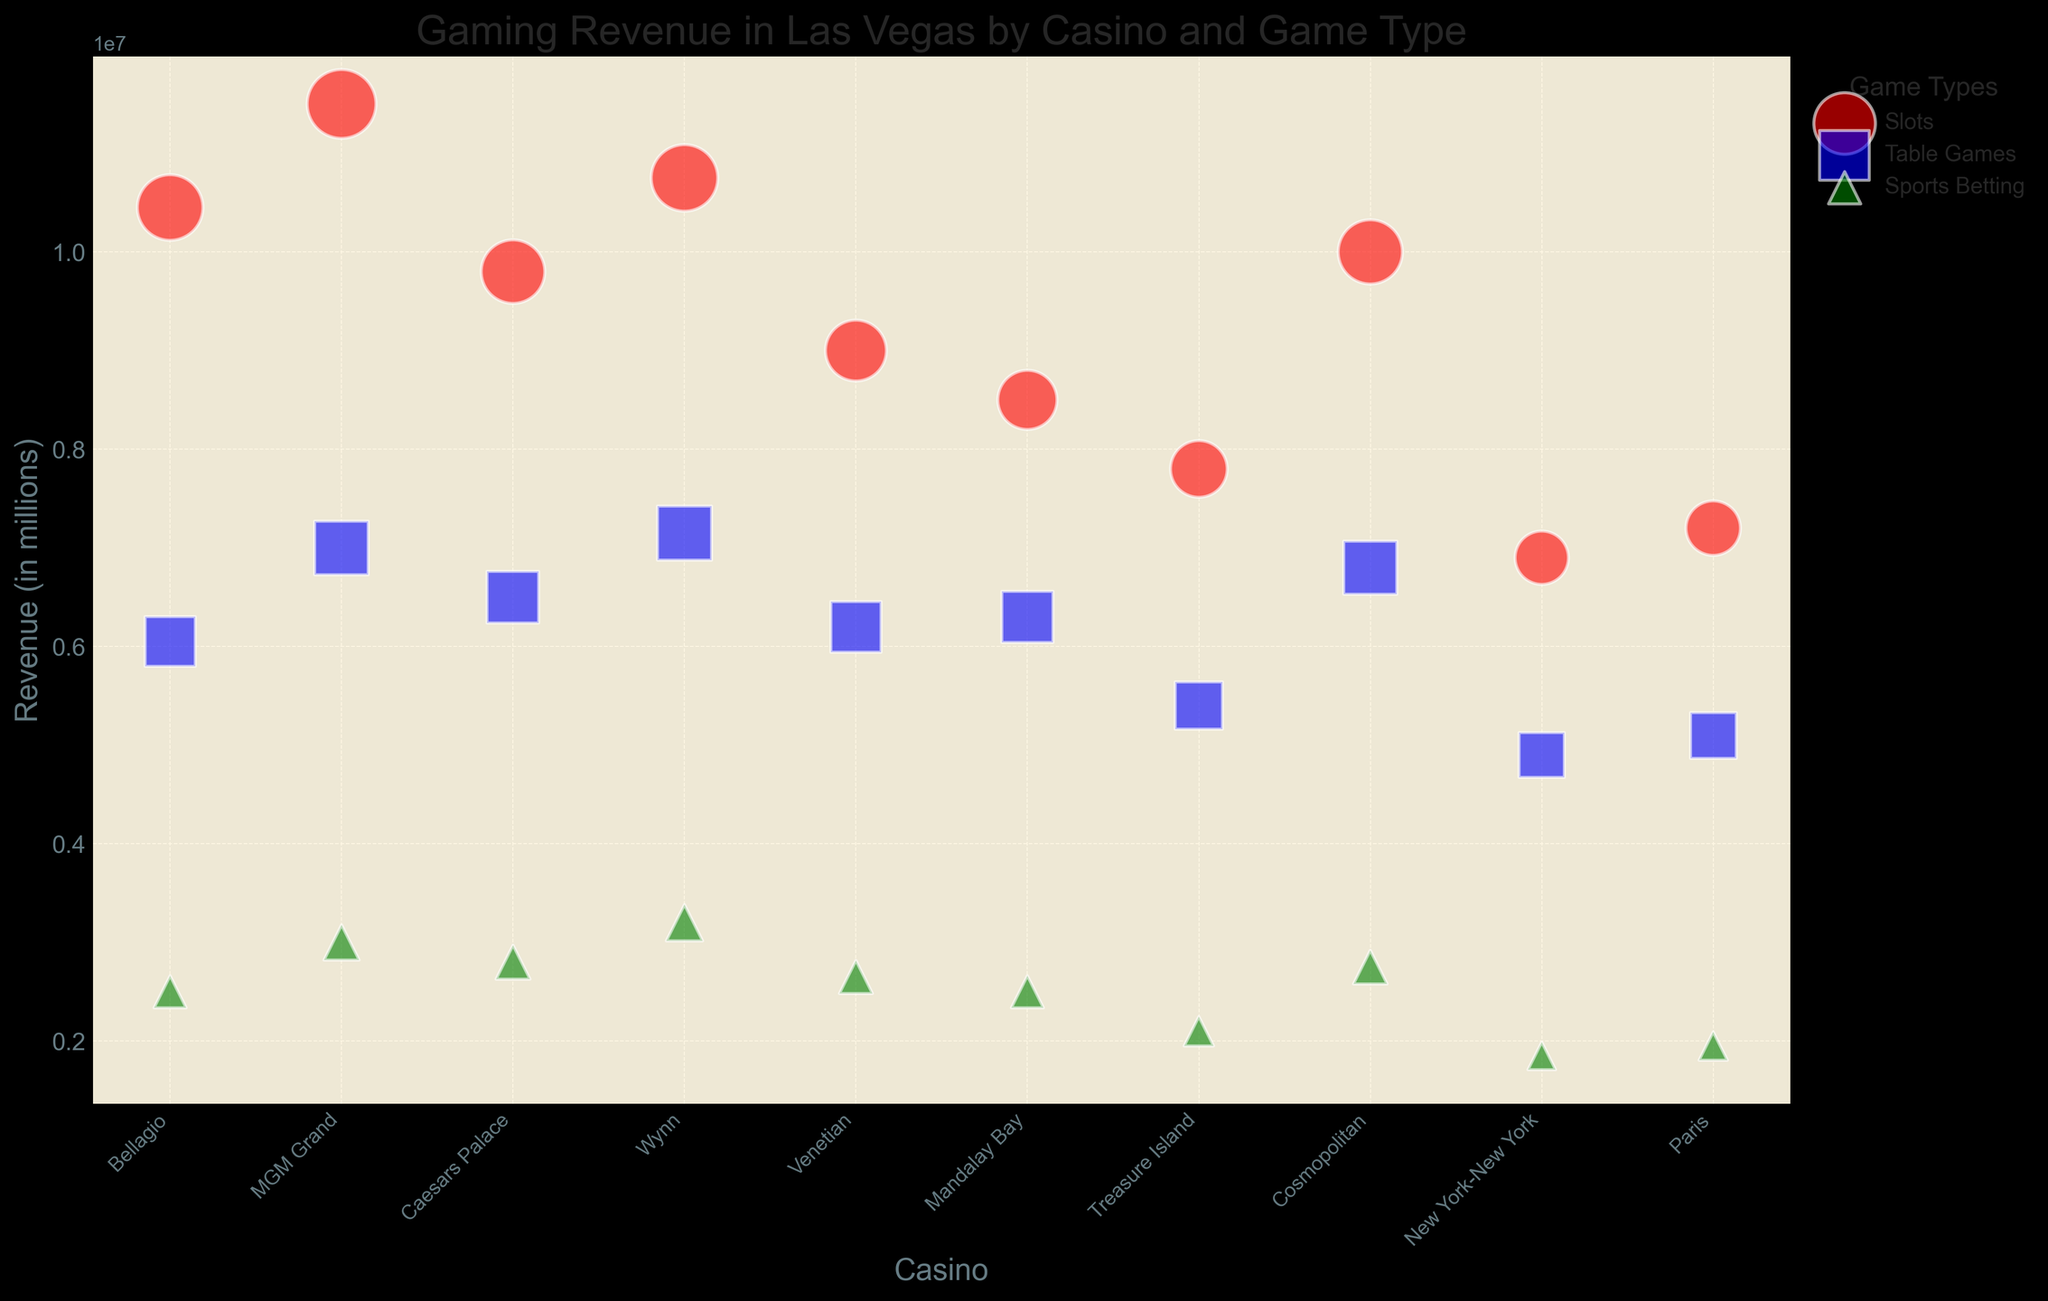What is the total revenue generated by Bellagio? To find the total revenue generated by Bellagio, sum the revenue from all game types at Bellagio: Slots ($10,450,000), Table Games ($6,050,000), and Sports Betting ($2,500,000). So, $10,450,000 + $6,050,000 + $2,500,000 = $19,000,000.
Answer: $19,000,000 Which casino generates the highest revenue from Slots? To determine the casino with the highest revenue from Slots, compare the revenue from Slots for all casinos. MGM Grand generates the highest revenue from Slots at $11,500,000.
Answer: MGM Grand Compare the revenue from Table Games at Wynn and Caesars Palace. Which one is higher? Wynn's revenue from Table Games is $7,150,000, while Caesars Palace has $6,500,000 from Table Games. Wynn's revenue is higher.
Answer: Wynn What is the average revenue generated from Sports Betting across all casinos? To find the average, sum the revenue from Sports Betting for all casinos and then divide by the number of casinos. Sum: $2,500,000 + $3,000,000 + $2,800,000 + $3,200,000 + $2,650,000 + $2,500,000 + $2,100,000 + $2,750,000 + $1,850,000 + $1,950,000 = $25,300,000. Number of casinos: 10. Average = $25,300,000 / 10 = $2,530,000.
Answer: $2,530,000 Which game type generally has the largest bubbles on the chart? By visually comparing the bubbles, those representing 'Slots' appear to be the largest overall, indicating higher revenues.
Answer: Slots Is there any casino where the revenue from Sports Betting is higher than from Table Games? For each casino, compare the revenues from Sports Betting and Table Games. There is no casino where Sports Betting revenue exceeds Table Games revenue.
Answer: No Which game type contributes the least to the total revenue of Mandalay Bay? Compare the revenues for different game types at Mandalay Bay: Slots ($8,500,000), Table Games ($6,300,000), and Sports Betting ($2,500,000). Sports Betting has the least revenue.
Answer: Sports Betting 